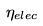<formula> <loc_0><loc_0><loc_500><loc_500>\eta _ { e l e c }</formula> 